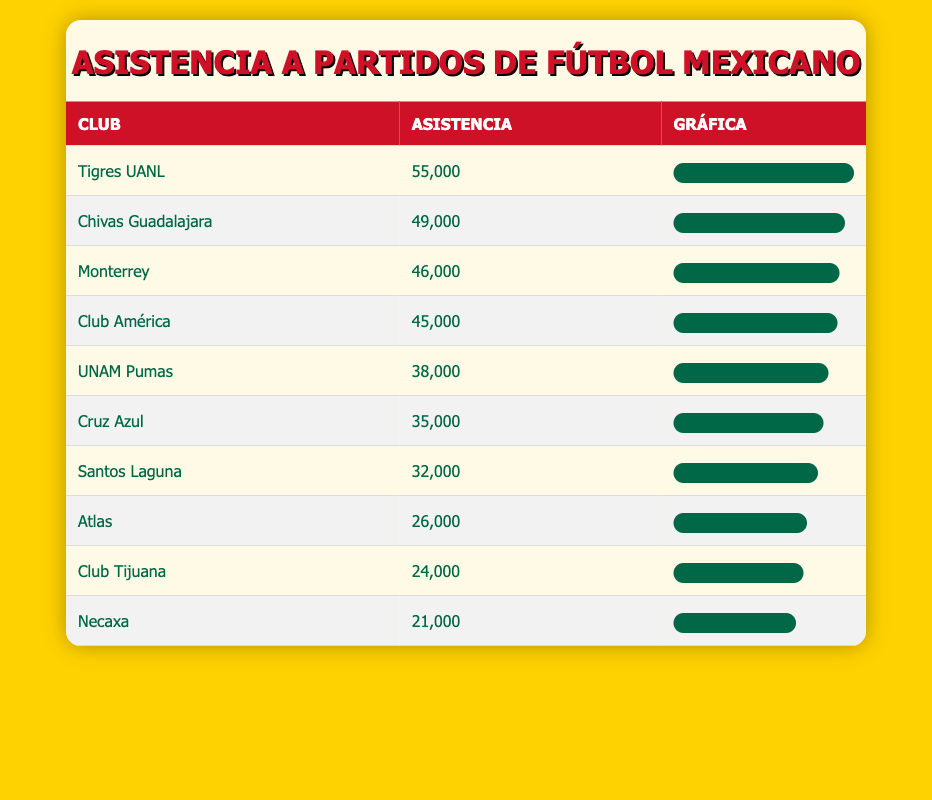What is the attendance figure for Tigres UANL? From the table, the row for Tigres UANL shows an attendance figure of 55,000.
Answer: 55,000 Which club has the lowest attendance? Looking at the attendance figures in the table, the lowest value is for Necaxa with an attendance of 21,000.
Answer: Necaxa What is the difference in attendance between Chivas Guadalajara and Club América? Chivas Guadalajara has an attendance of 49,000 and Club América has 45,000. The difference is 49,000 - 45,000 = 4,000.
Answer: 4,000 Is the attendance for Monterrey greater than 40,000? The attendance for Monterrey is 46,000, which is indeed greater than 40,000.
Answer: Yes What is the total attendance for the clubs that have over 40,000 in attendance? The clubs with over 40,000 are Tigres UANL (55,000), Chivas Guadalajara (49,000), Monterrey (46,000), and Club América (45,000). Their total attendance is 55,000 + 49,000 + 46,000 + 45,000 = 195,000.
Answer: 195,000 What percentage of attendance does Santos Laguna represent compared to the highest attendance? Santos Laguna's attendance is 32,000, and the highest is 55,000. The percentage is (32,000 / 55,000) * 100 = 58.18%.
Answer: 58.18% How many clubs have attendance figures below 30,000? The clubs with attendance below 30,000 are Club Tijuana (24,000), Atlas (26,000), and Necaxa (21,000). This adds up to 3 clubs.
Answer: 3 If you combined the attendance of Cruz Azul and UNAM Pumas, what would be the total? Cruz Azul has an attendance of 35,000 and UNAM Pumas has 38,000. Adding these two gives 35,000 + 38,000 = 73,000.
Answer: 73,000 Which football club had an attendance that was closest to the average of all clubs? First, we must calculate the average attendance. The total attendance is 45000 + 35000 + 49000 + 38000 + 55000 + 46000 + 24000 + 32000 + 26000 + 21000 = 450000. There are 10 clubs, so the average is 450000 / 10 = 45000. The club closest to this average is Club América with 45,000.
Answer: Club América 